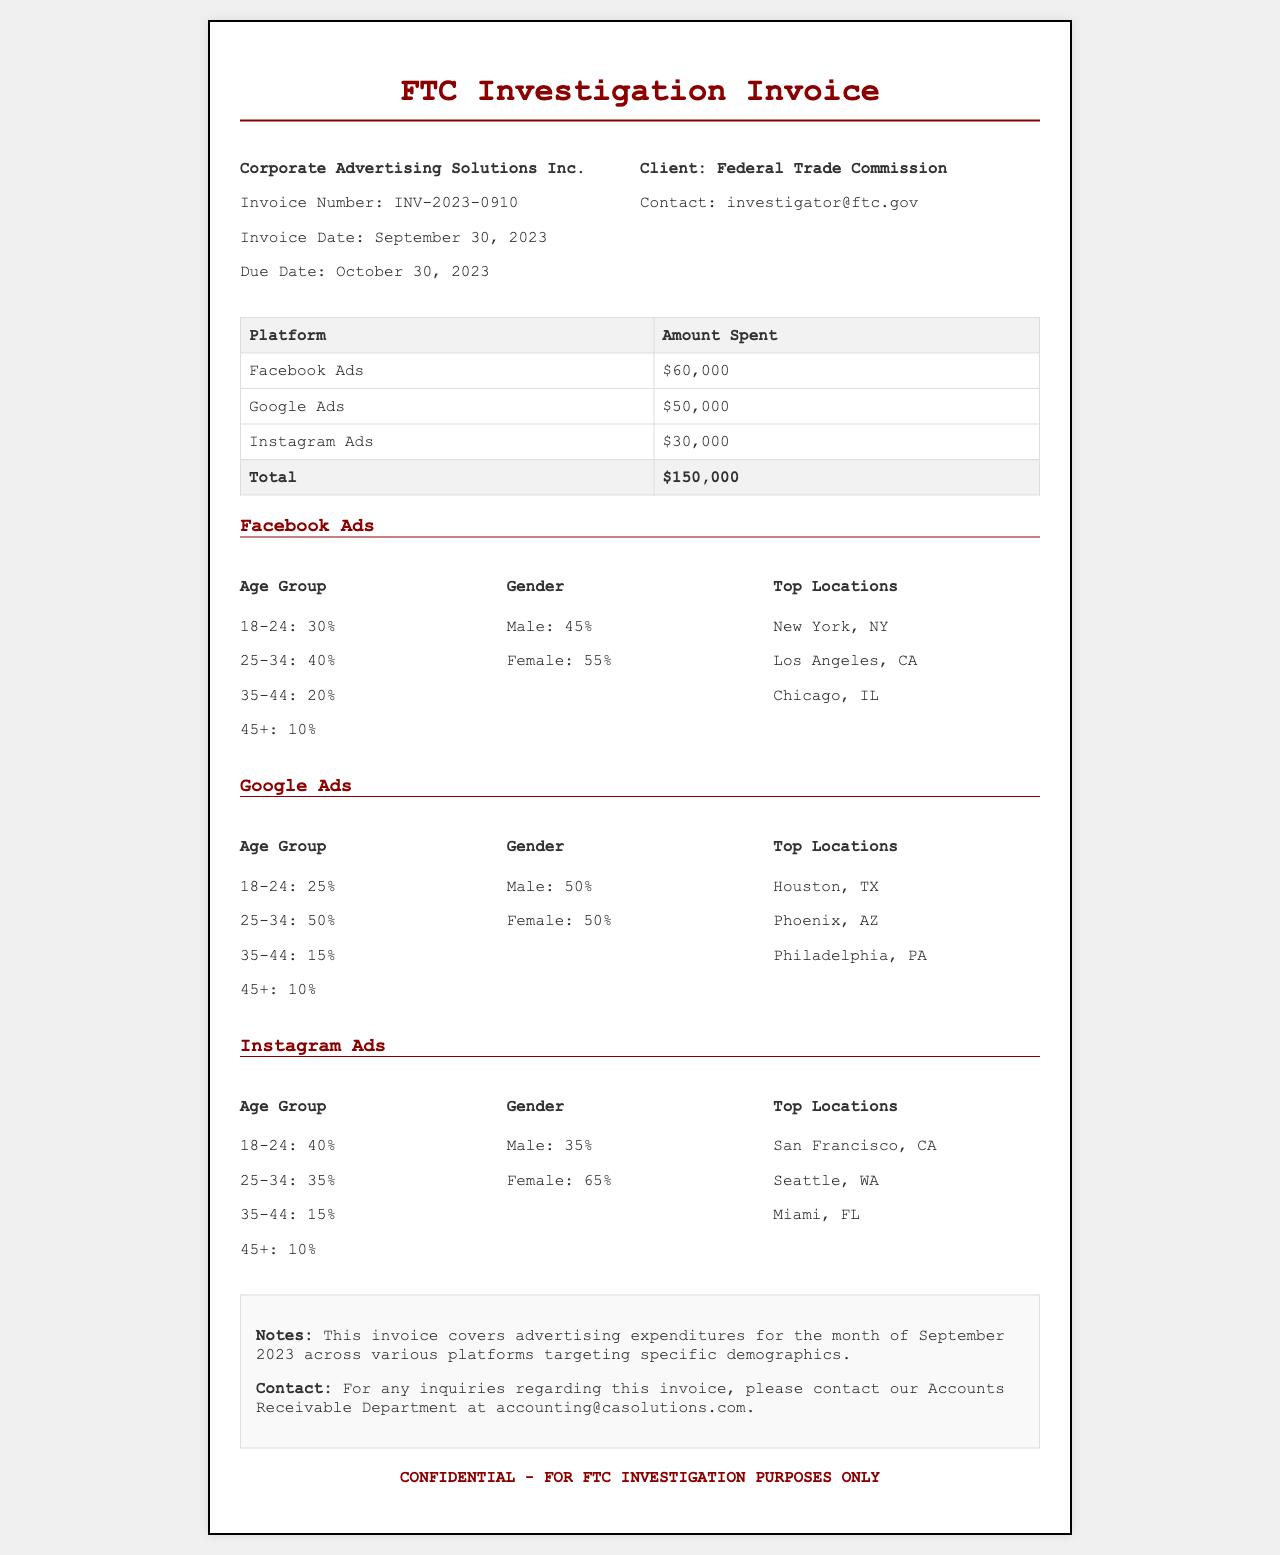What is the invoice number? The invoice number is provided in the header section of the document, labeled as "Invoice Number."
Answer: INV-2023-0910 What is the total amount spent on advertising? The total amount spent is the sum of amounts across all platforms shown in the table.
Answer: $150,000 Which platform had the highest advertising spending? The platform with the highest spending is indicated in the table showcasing individual expenditures.
Answer: Facebook Ads What percentage of the Facebook Ads audience is aged 25-34? The age distribution for Facebook Ads lists the percentage for the 25-34 age group specifically.
Answer: 40% How much was spent on Instagram Ads? The amount spent specifically on Instagram Ads is detailed in the spending breakdown table.
Answer: $30,000 What is the due date for the invoice? The due date for payment is stated clearly in the invoice header section.
Answer: October 30, 2023 Which state had the top location for Google Ads? The top locations for Google Ads are provided, and one of them is selected as the top state.
Answer: Houston, TX What percentage of the Instagram Ads audience is female? The gender breakdown for the Instagram Ads audience specifies the percentage of females.
Answer: 65% What is the contact email for the Accounts Receivable Department? The contact email for inquiries related to the invoice is included in the summary section.
Answer: accounting@casolutions.com 